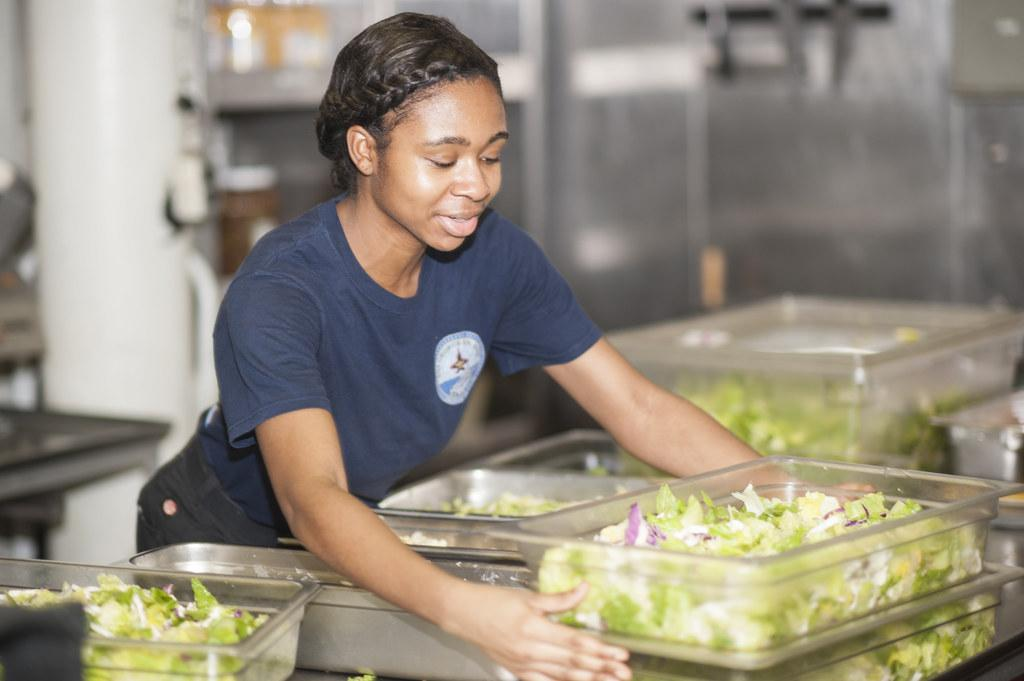What is the woman doing in the image? The woman is standing at the table in the image. What can be seen on the table? Containers and vegetables are present on the table. What is visible in the background of the image? There is a wall and equipment visible in the background of the image. Can you hear a whistle in the image? There is no whistle present in the image, and therefore no sound can be heard. 